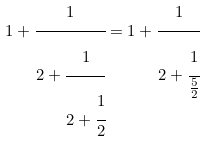<formula> <loc_0><loc_0><loc_500><loc_500>1 + { \cfrac { 1 } { 2 + { \cfrac { 1 } { 2 + { \cfrac { 1 } { 2 } } } } } } = 1 + { \cfrac { 1 } { 2 + { \cfrac { 1 } { \frac { 5 } { 2 } } } } }</formula> 